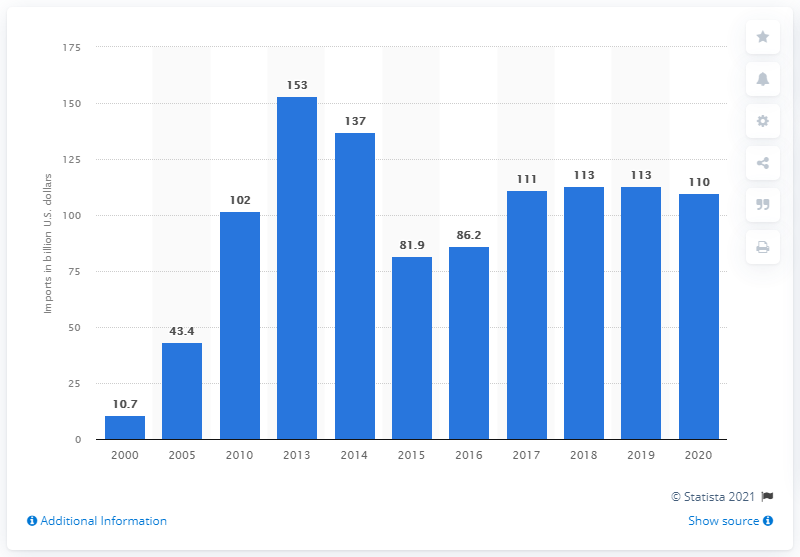Indicate a few pertinent items in this graphic. In 2020, the value of Russian imports of machinery, equipment, and transport means was 110 billion dollars. In 2013, the value of Russian imports of machinery, equipment, and transport was 153... 